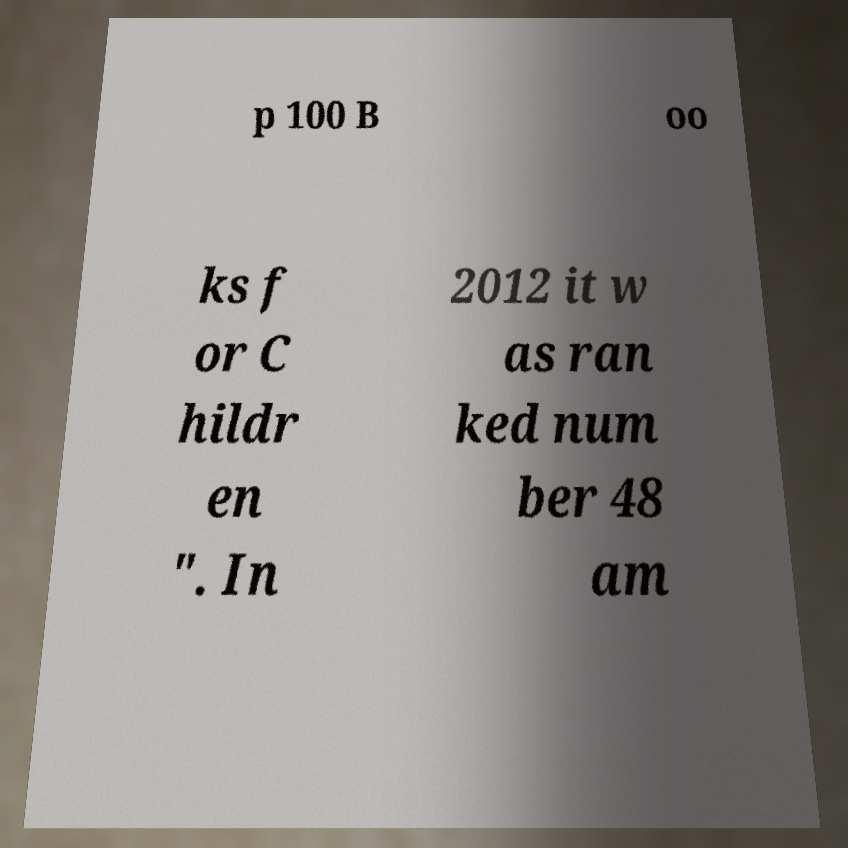I need the written content from this picture converted into text. Can you do that? p 100 B oo ks f or C hildr en ". In 2012 it w as ran ked num ber 48 am 